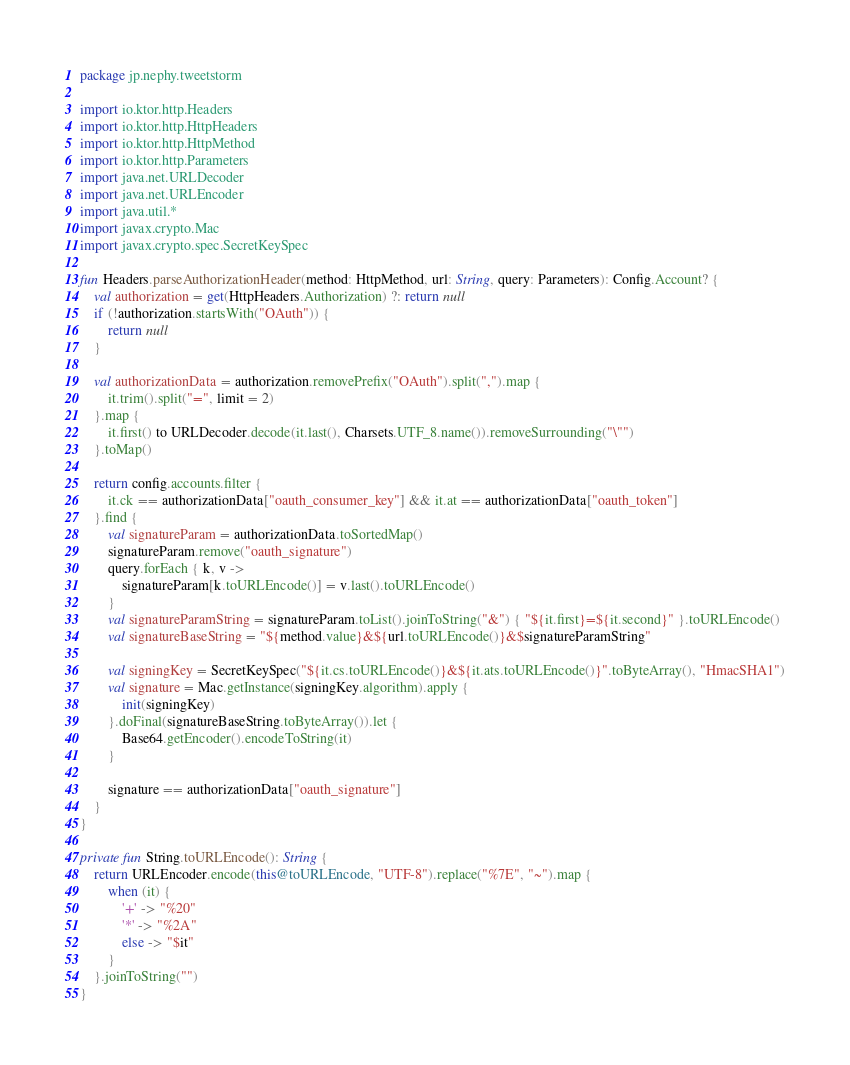Convert code to text. <code><loc_0><loc_0><loc_500><loc_500><_Kotlin_>package jp.nephy.tweetstorm

import io.ktor.http.Headers
import io.ktor.http.HttpHeaders
import io.ktor.http.HttpMethod
import io.ktor.http.Parameters
import java.net.URLDecoder
import java.net.URLEncoder
import java.util.*
import javax.crypto.Mac
import javax.crypto.spec.SecretKeySpec

fun Headers.parseAuthorizationHeader(method: HttpMethod, url: String, query: Parameters): Config.Account? {
    val authorization = get(HttpHeaders.Authorization) ?: return null
    if (!authorization.startsWith("OAuth")) {
        return null
    }

    val authorizationData = authorization.removePrefix("OAuth").split(",").map {
        it.trim().split("=", limit = 2)
    }.map {
        it.first() to URLDecoder.decode(it.last(), Charsets.UTF_8.name()).removeSurrounding("\"")
    }.toMap()

    return config.accounts.filter {
        it.ck == authorizationData["oauth_consumer_key"] && it.at == authorizationData["oauth_token"]
    }.find {
        val signatureParam = authorizationData.toSortedMap()
        signatureParam.remove("oauth_signature")
        query.forEach { k, v ->
            signatureParam[k.toURLEncode()] = v.last().toURLEncode()
        }
        val signatureParamString = signatureParam.toList().joinToString("&") { "${it.first}=${it.second}" }.toURLEncode()
        val signatureBaseString = "${method.value}&${url.toURLEncode()}&$signatureParamString"

        val signingKey = SecretKeySpec("${it.cs.toURLEncode()}&${it.ats.toURLEncode()}".toByteArray(), "HmacSHA1")
        val signature = Mac.getInstance(signingKey.algorithm).apply {
            init(signingKey)
        }.doFinal(signatureBaseString.toByteArray()).let {
            Base64.getEncoder().encodeToString(it)
        }

        signature == authorizationData["oauth_signature"]
    }
}

private fun String.toURLEncode(): String {
    return URLEncoder.encode(this@toURLEncode, "UTF-8").replace("%7E", "~").map {
        when (it) {
            '+' -> "%20"
            '*' -> "%2A"
            else -> "$it"
        }
    }.joinToString("")
}
</code> 